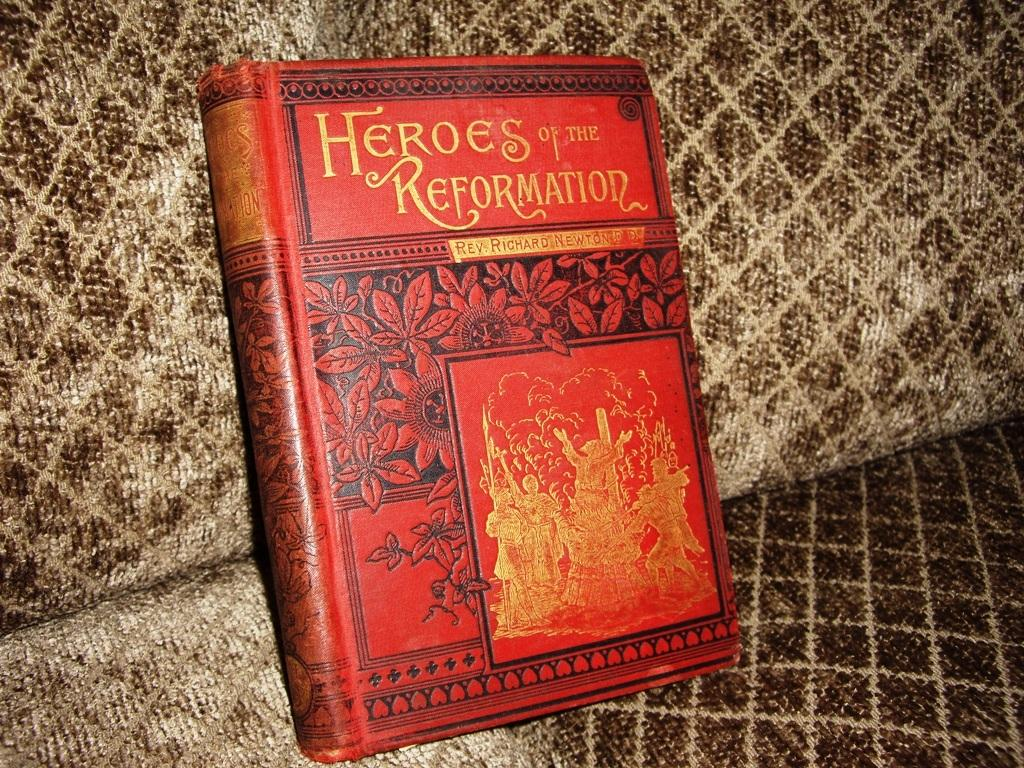<image>
Summarize the visual content of the image. A book with the title of Heroes of the Reformation. 